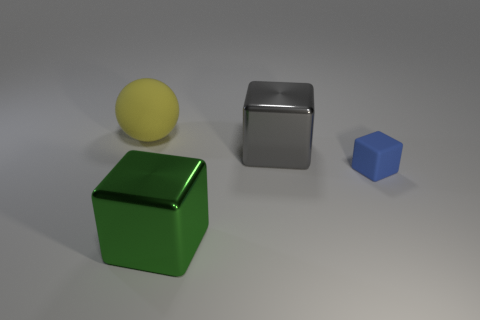Add 4 small blue rubber objects. How many objects exist? 8 Subtract all balls. How many objects are left? 3 Subtract all big red rubber objects. Subtract all metallic blocks. How many objects are left? 2 Add 4 gray blocks. How many gray blocks are left? 5 Add 1 brown rubber spheres. How many brown rubber spheres exist? 1 Subtract 1 green blocks. How many objects are left? 3 